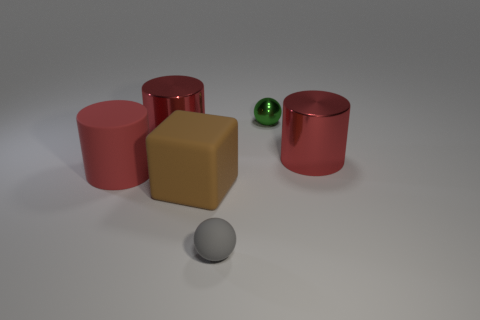Add 2 small yellow matte blocks. How many objects exist? 8 Subtract all spheres. How many objects are left? 4 Add 6 small green metallic things. How many small green metallic things are left? 7 Add 1 gray matte blocks. How many gray matte blocks exist? 1 Subtract 0 red balls. How many objects are left? 6 Subtract all tiny gray matte things. Subtract all brown matte blocks. How many objects are left? 4 